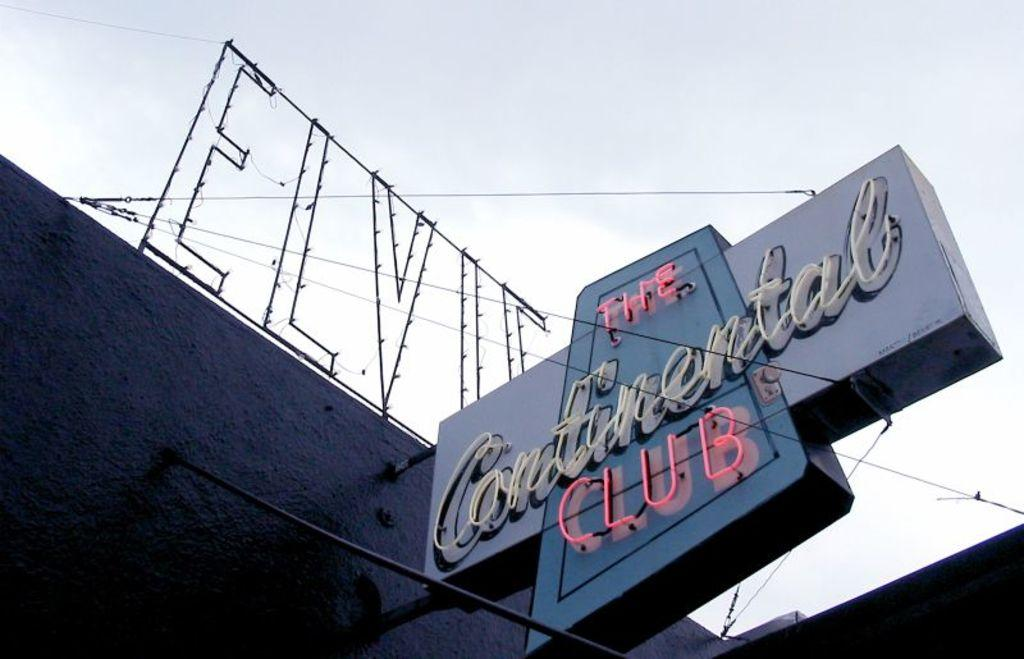<image>
Render a clear and concise summary of the photo. A lit sign attached to a building advertises The Continental Club. 